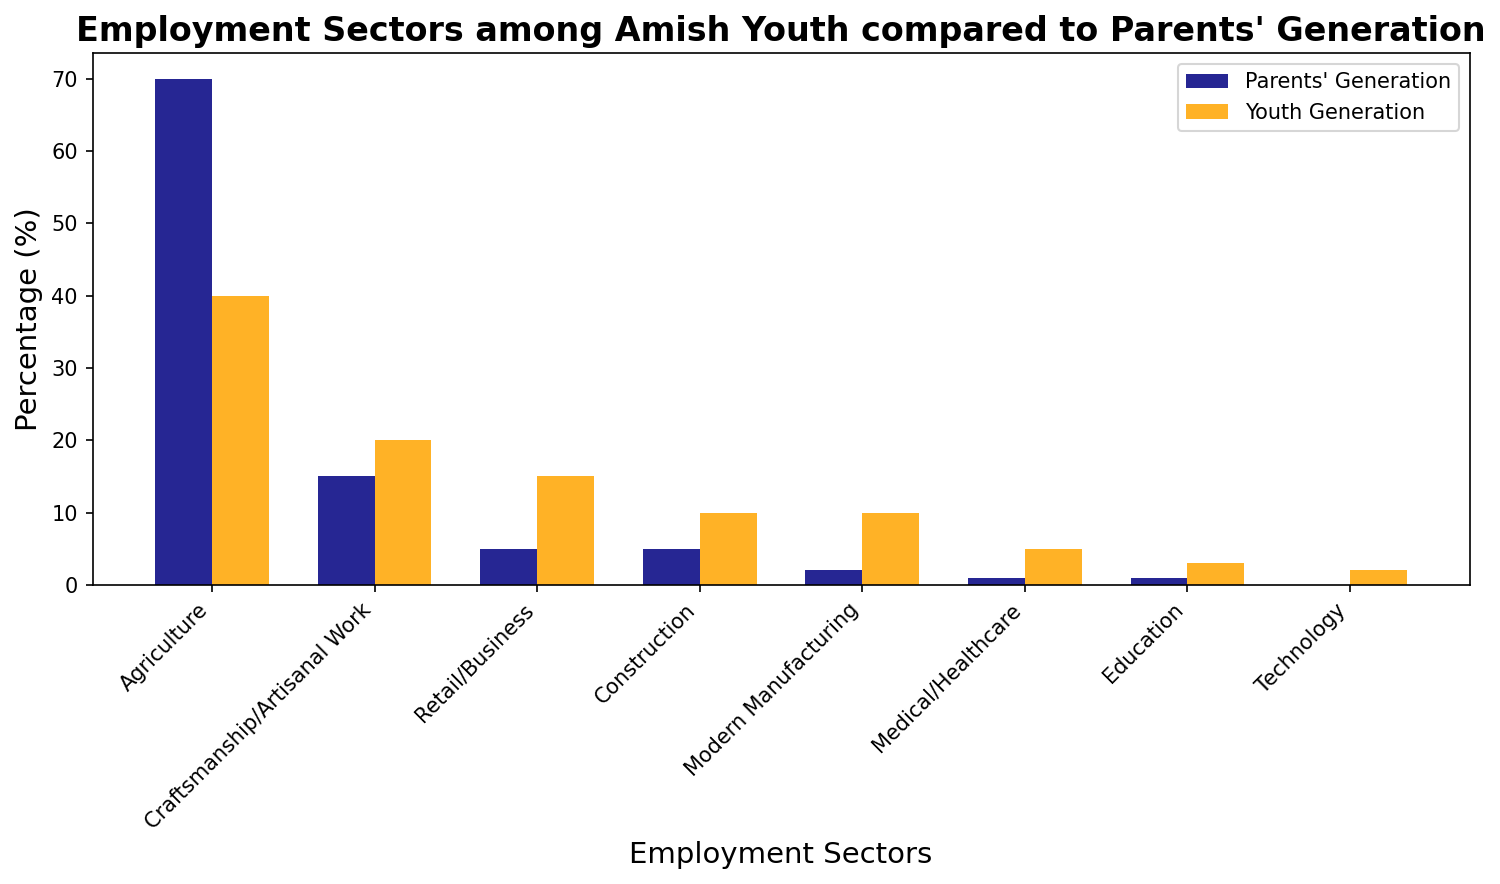What percentage of the parents' generation worked in Agriculture? According to the figure, the bar representing the percentage of the parents' generation in Agriculture is at 70%.
Answer: 70% Which sector shows the largest increase in employment from the parents' generation to the youth generation? By comparing the bars, Modern Manufacturing shows the largest increase, with a rise from 2% in the parents' generation to 10% in the youth generation.
Answer: Modern Manufacturing What's the total percentage of Amish youth working in Agriculture, Retail/Business, and Technology combined? Add the percentages for youth in Agriculture (40%), Retail/Business (15%), and Technology (2%): 40% + 15% + 2% = 57%.
Answer: 57% In which sector does the youth generation have the lowest percentage compared to their parents' generation? By looking at the bars, Agriculture has the largest decrease, dropping from 70% in the parents' generation to 40% in the youth generation.
Answer: Agriculture Are there any employment sectors where the percentage of the youth generation equals the percentage of the parents' generation? Based on the bars, there are no sectors where the percentages are equal; all sectors show a change between the two generations.
Answer: No Which sector has a higher percentage in the youth generation than the parents' generation but still remains under 10% for the youth generation? By comparing the bars, Education increases from 1% to 3% in the youth generation, which meets the criteria.
Answer: Education How much difference is there between the percentage of youth and parents working in Construction? The percentage for Construction is 10% for the youth and 5% for the parents. The difference is 10% - 5% = 5%.
Answer: 5% Which color represents the parents' generation in the bar chart? The color used for the parents' generation bars is navy blue.
Answer: navy blue What is the combined percentage of youth in Medical/Healthcare and Education? Add the percentages for Medical/Healthcare (5%) and Education (3%): 5% + 3% = 8%.
Answer: 8% 